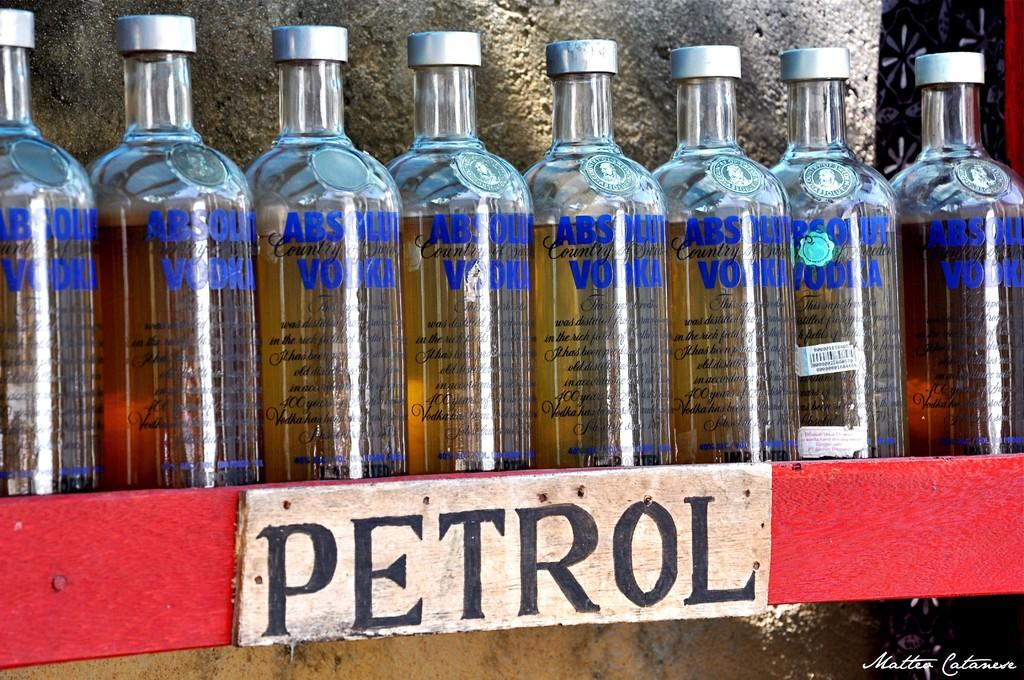<image>
Write a terse but informative summary of the picture. Absolut Vodka bottles lined up next to each other on a red shelf  with the word Petrol underneath. 